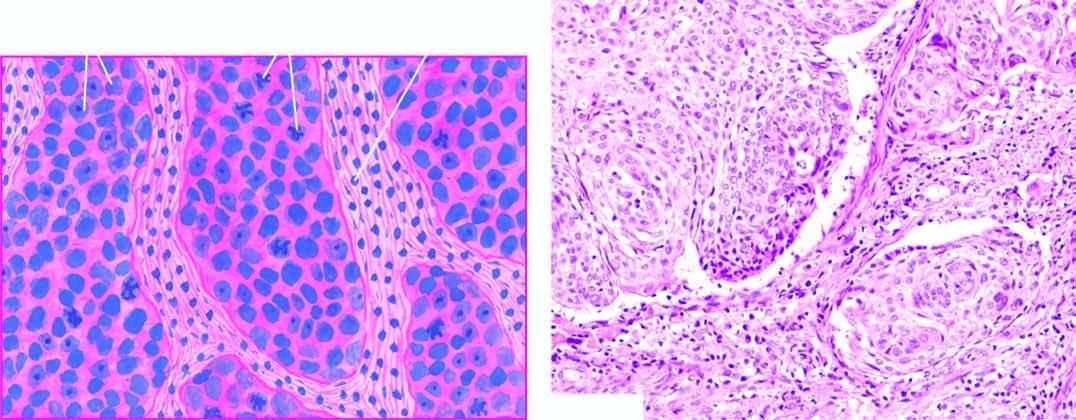s common histologic type epidermoid carcinoma showing the pattern of a moderatelydifferentiated non-keratinising large cell carcinoma?
Answer the question using a single word or phrase. Yes 